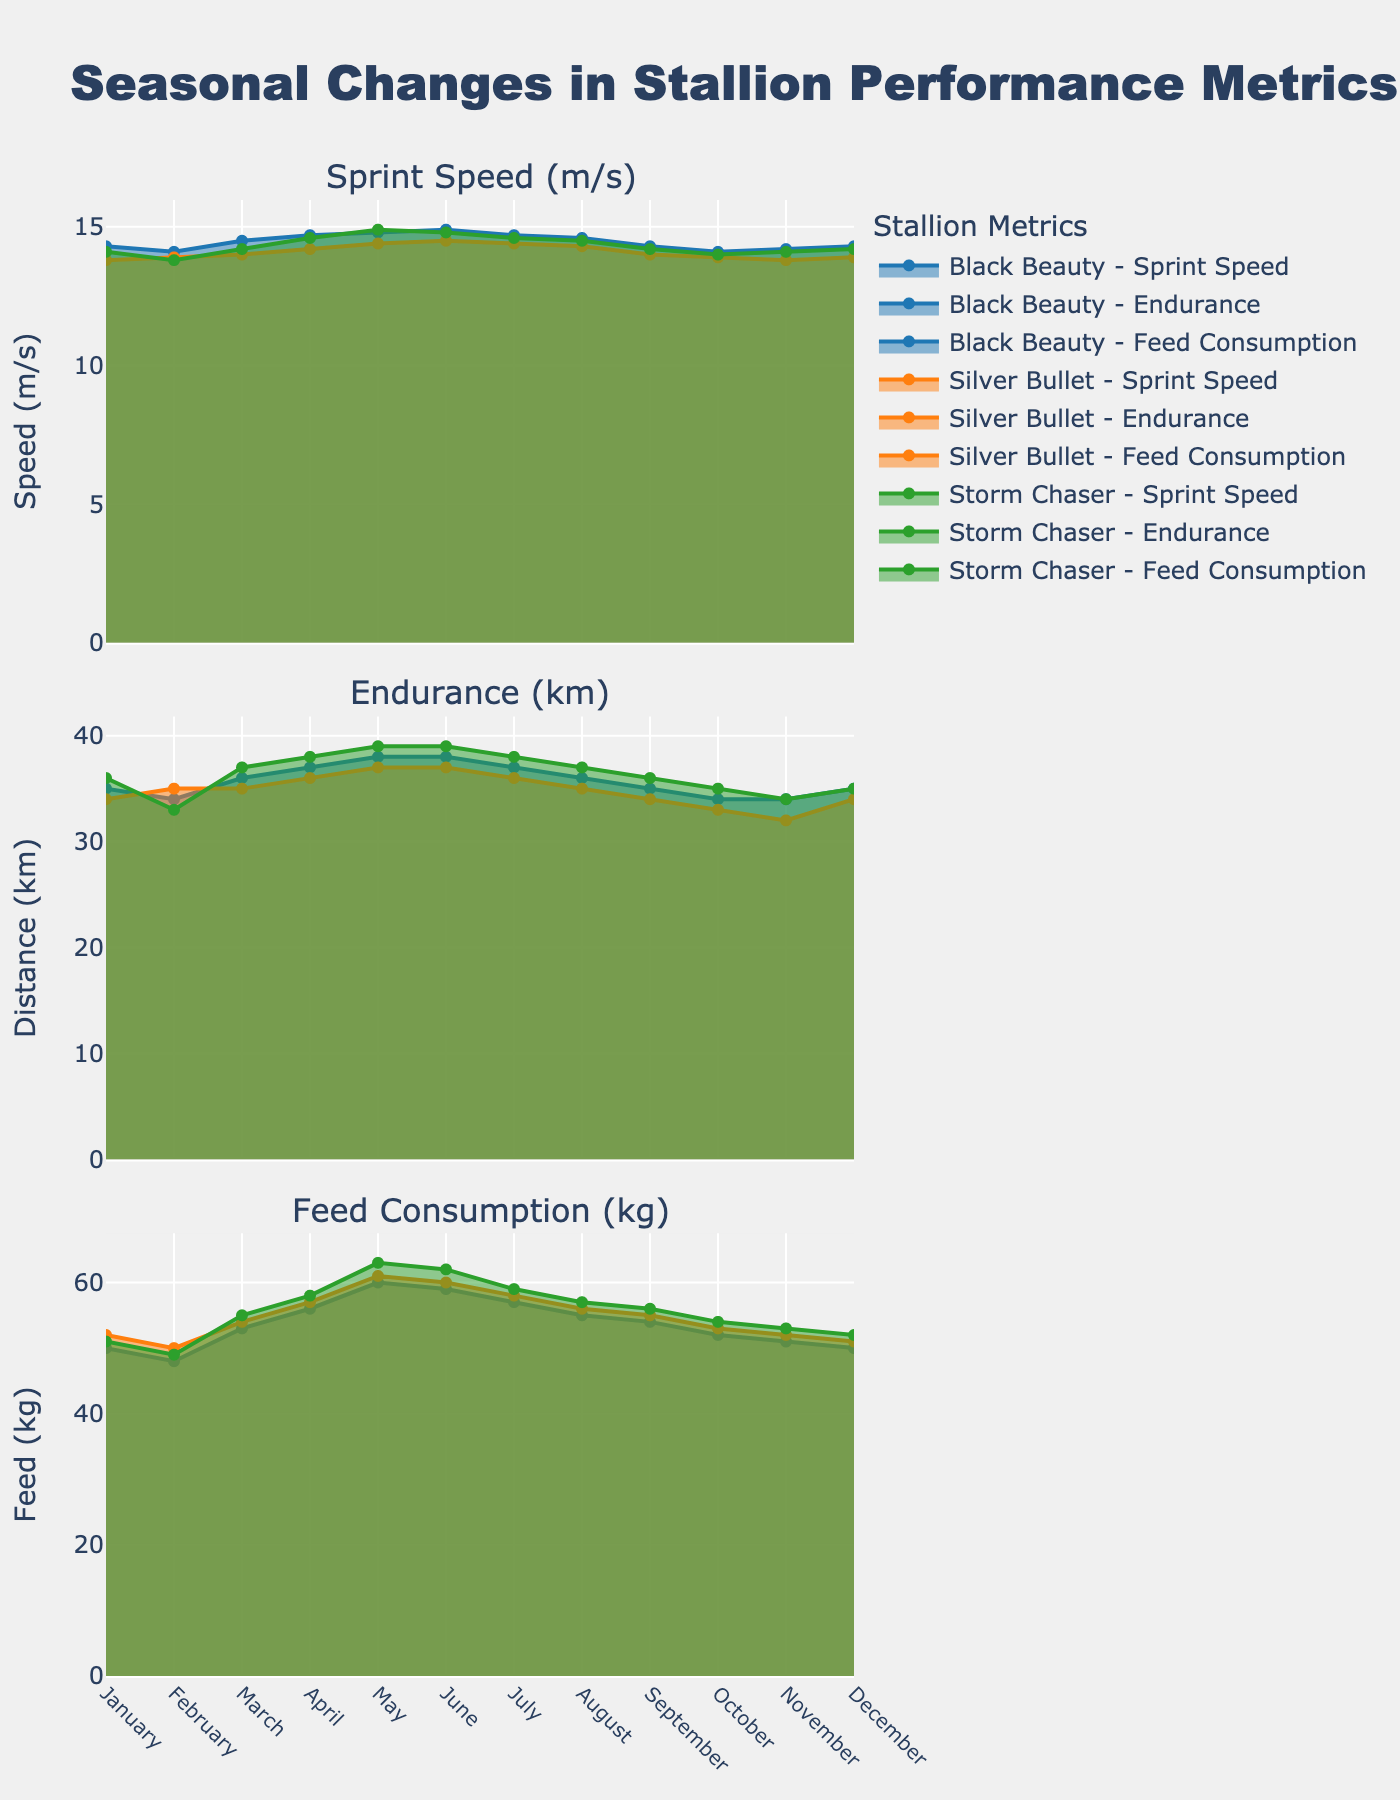What is the overall trend in sprint speed for Black Beauty throughout the year? Observing the subplot for sprint speed, the trend for Black Beauty shows an increase from January to May, stabilizes around June, and then gradually decreases until the end of the year.
Answer: Increasing then decreasing Which month has the highest endurance metric for Storm Chaser? Looking at the subplot for endurance, the highest point for Storm Chaser can be seen in May, reaching 39 km.
Answer: May How does feed consumption in June compare between Silver Bullet and Black Beauty? By examining the feed consumption subplot, in June, Black Beauty consumes 59 kg, and Silver Bullet consumes 60 kg.
Answer: Silver Bullet consumes 1 kg more What is the combined sprint speed of all three stallions in April? The sprint speed values for April are: Black Beauty (14.7 m/s), Silver Bullet (14.2 m/s), and Storm Chaser (14.6 m/s). Adding these gives 14.7 + 14.2 + 14.6 = 43.5 m/s.
Answer: 43.5 m/s Does any stallion have a constant feed consumption throughout the year? Observing the feed consumption subplot of all three stallions, no stallion maintains a constant feed consumption; their values fluctuate each month.
Answer: No Which stallion shows the most significant drop in endurance from August to September? Checking the subplots for endurance metrics, Black Beauty drops from 36 km to 35 km (1 km), Silver Bullet from 35 km to 34 km (1 km), and Storm Chaser from 37 km to 36 km (1 km). So, all stallions have an equal drop.
Answer: All have equal drop What is the range of sprint speed for Silver Bullet observed in the subplot? In the subplot for sprint speed, Silver Bullet's speed ranges from a minimum of 13.8 m/s to a maximum of 14.5 m/s.
Answer: 13.8 to 14.5 m/s Which stallion has the highest feed consumption in December? From the subplot related to feed consumption in December, Storm Chaser consumes the most at 52 kg.
Answer: Storm Chaser How does the monthly variation in Black Beauty's endurance compare to Storm Chaser's? Observing the endurance subplot, Black Beauty shows smaller monthly variations, mostly around 1 km, whereas Storm Chaser displays larger variations, with a jump of up to 2 km in some months.
Answer: Storm Chaser has larger variations 